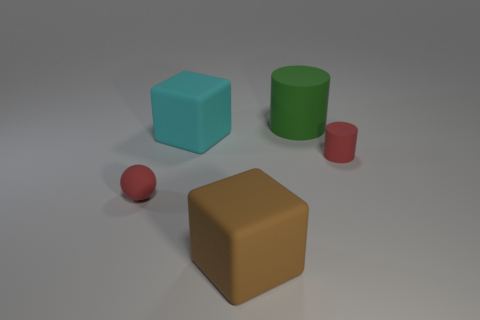There is a large rubber cube that is behind the small red cylinder; is it the same color as the rubber ball behind the large brown block?
Your answer should be compact. No. What color is the tiny thing on the left side of the large brown rubber cube that is right of the large block behind the red matte cylinder?
Ensure brevity in your answer.  Red. There is a tiny red object that is behind the ball; are there any brown rubber blocks that are behind it?
Keep it short and to the point. No. There is a red object that is on the left side of the green matte cylinder; is it the same shape as the cyan rubber thing?
Provide a succinct answer. No. How many blocks are either large brown rubber things or big cyan things?
Ensure brevity in your answer.  2. What number of matte cubes are there?
Make the answer very short. 2. What is the size of the brown block that is to the left of the green rubber cylinder that is right of the red matte ball?
Provide a succinct answer. Large. How many other objects are there of the same size as the brown rubber thing?
Provide a short and direct response. 2. How many tiny red objects are on the left side of the green cylinder?
Give a very brief answer. 1. How big is the matte ball?
Provide a short and direct response. Small. 